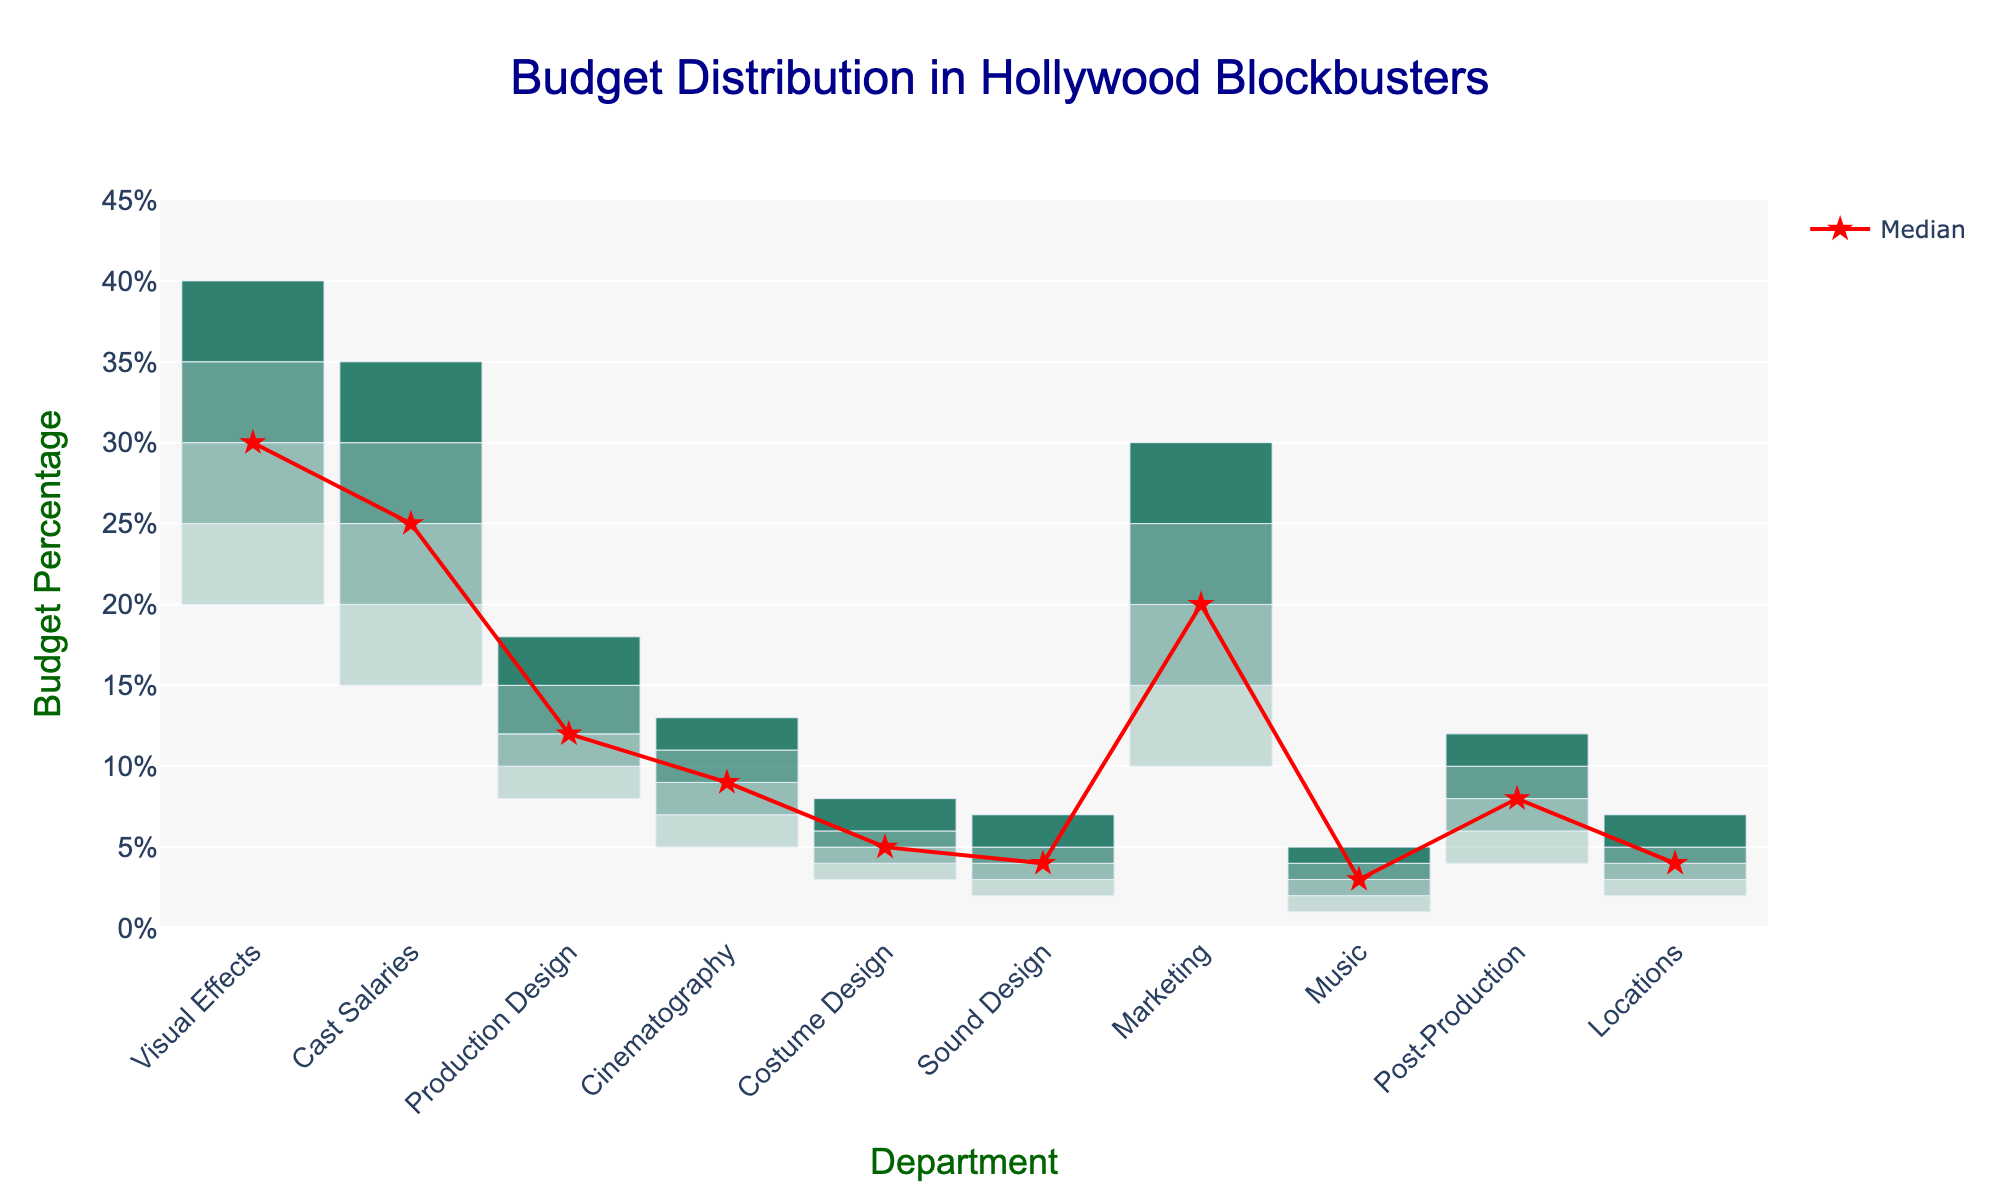what is the title of the plot? The title is displayed at the top center of the plot in a larger, dark blue font, reading "Budget Distribution in Hollywood Blockbusters"
Answer: Budget Distribution in Hollywood Blockbusters Which department has the highest median budget percentage? By examining the red lines (medians) for each department, Visual Effects stands out as having the highest median budget percentage at 30%
Answer: Visual Effects What is the range of the budget percentage for Costume Design? The range is the difference between the maximum and minimum values, which for Costume Design is 8% - 3% = 5%
Answer: 5% Which department has the smallest range in budget percentage? By identifying the departments with the smallest gap between their minimum and maximum values, Music has the narrowest range with 5% - 1% = 4%
Answer: Music Which department has a greater median budget percentage, Marketing or Sound Design? Compare the central red lines of these departments. Marketing’s median is at 20%, whereas Sound Design’s median is at 4%
Answer: Marketing What color is used to represent the Q3 to Max budget range? The range from Q3 to Max is represented with the darkest shade of green visible on the visual elements, being the fourth shade with a high transparency overlay
Answer: Dark green with 0.8 opacity What’s the difference between the Q1 and Q3 budget percentages for Cast Salaries? First, look at Q3 (30%) and Q1 (20%) for Cast Salaries and subtract to find the interquartile range: 30% - 20% = 10%
Answer: 10% Is the median budget percentage higher for Production Design or Cinematography? By comparing the medians marked by the red lines, Production Design has a median of 12%, whereas Cinematography’s median is 9%
Answer: Production Design Which department shows the widest distribution in budget percentage? The department with the broadest distribution needs to have the largest overall span from Min to Max. Visual Effects ranges from 20% to 40%, showing the widest distribution
Answer: Visual Effects 